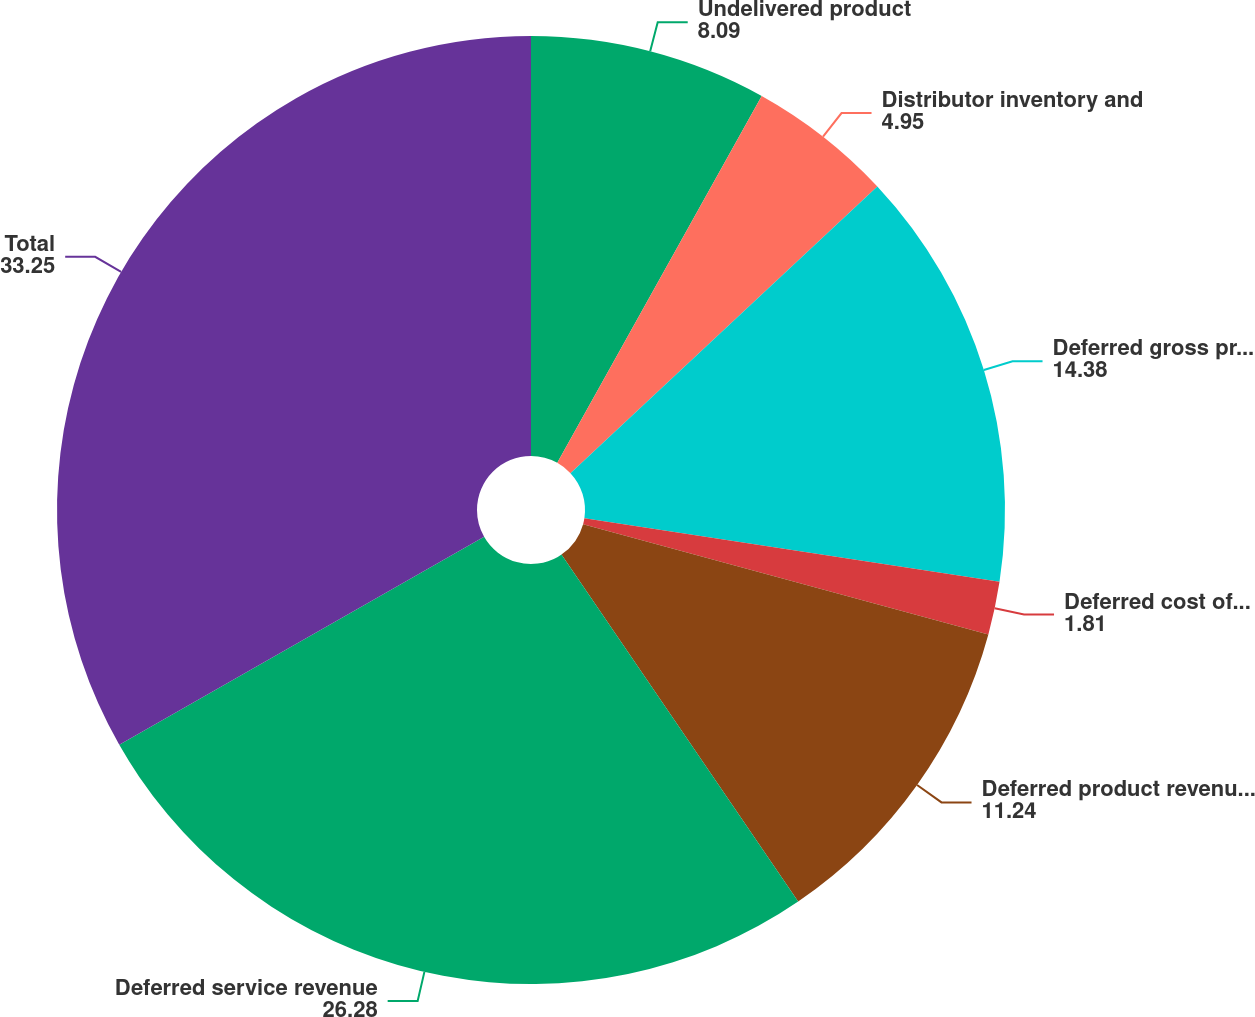Convert chart to OTSL. <chart><loc_0><loc_0><loc_500><loc_500><pie_chart><fcel>Undelivered product<fcel>Distributor inventory and<fcel>Deferred gross product revenue<fcel>Deferred cost of product<fcel>Deferred product revenue net<fcel>Deferred service revenue<fcel>Total<nl><fcel>8.09%<fcel>4.95%<fcel>14.38%<fcel>1.81%<fcel>11.24%<fcel>26.28%<fcel>33.25%<nl></chart> 